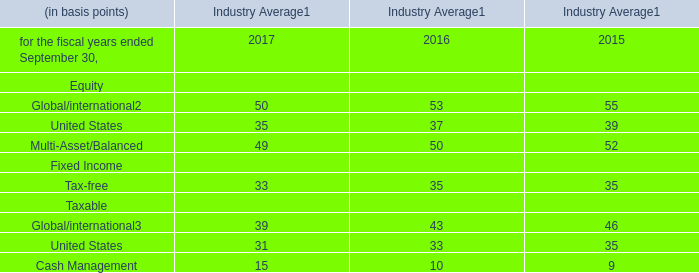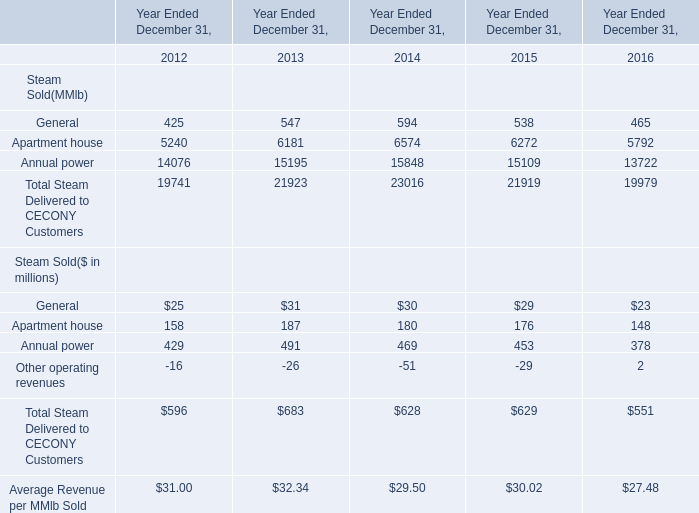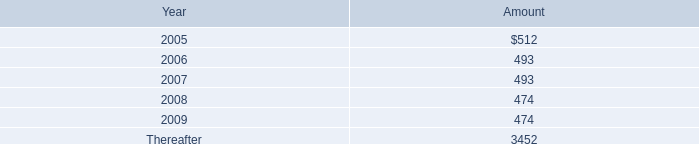What was the average value of General, Apartment house, Annual power in 2012? (in millions) 
Computations: (((25 + 158) + 429) / 3)
Answer: 204.0. 